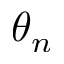Convert formula to latex. <formula><loc_0><loc_0><loc_500><loc_500>\theta _ { n }</formula> 